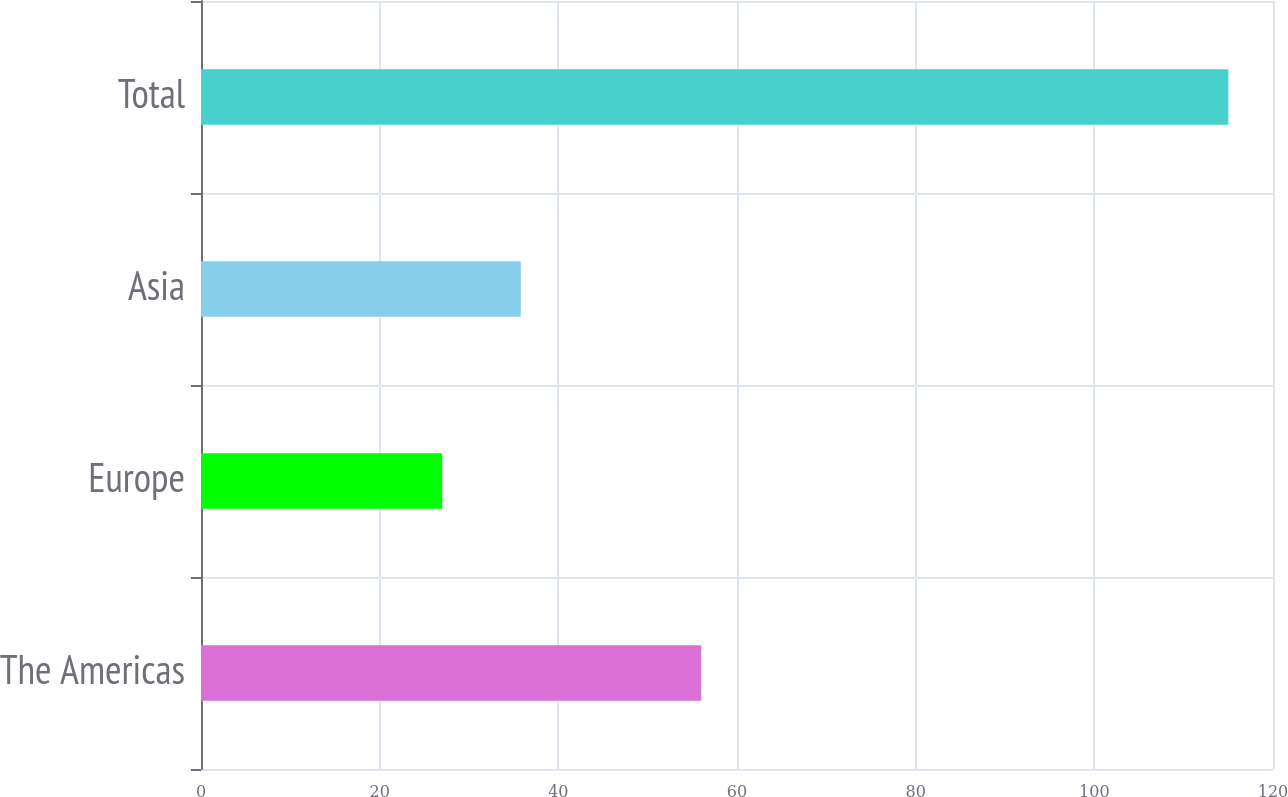<chart> <loc_0><loc_0><loc_500><loc_500><bar_chart><fcel>The Americas<fcel>Europe<fcel>Asia<fcel>Total<nl><fcel>56<fcel>27<fcel>35.8<fcel>115<nl></chart> 